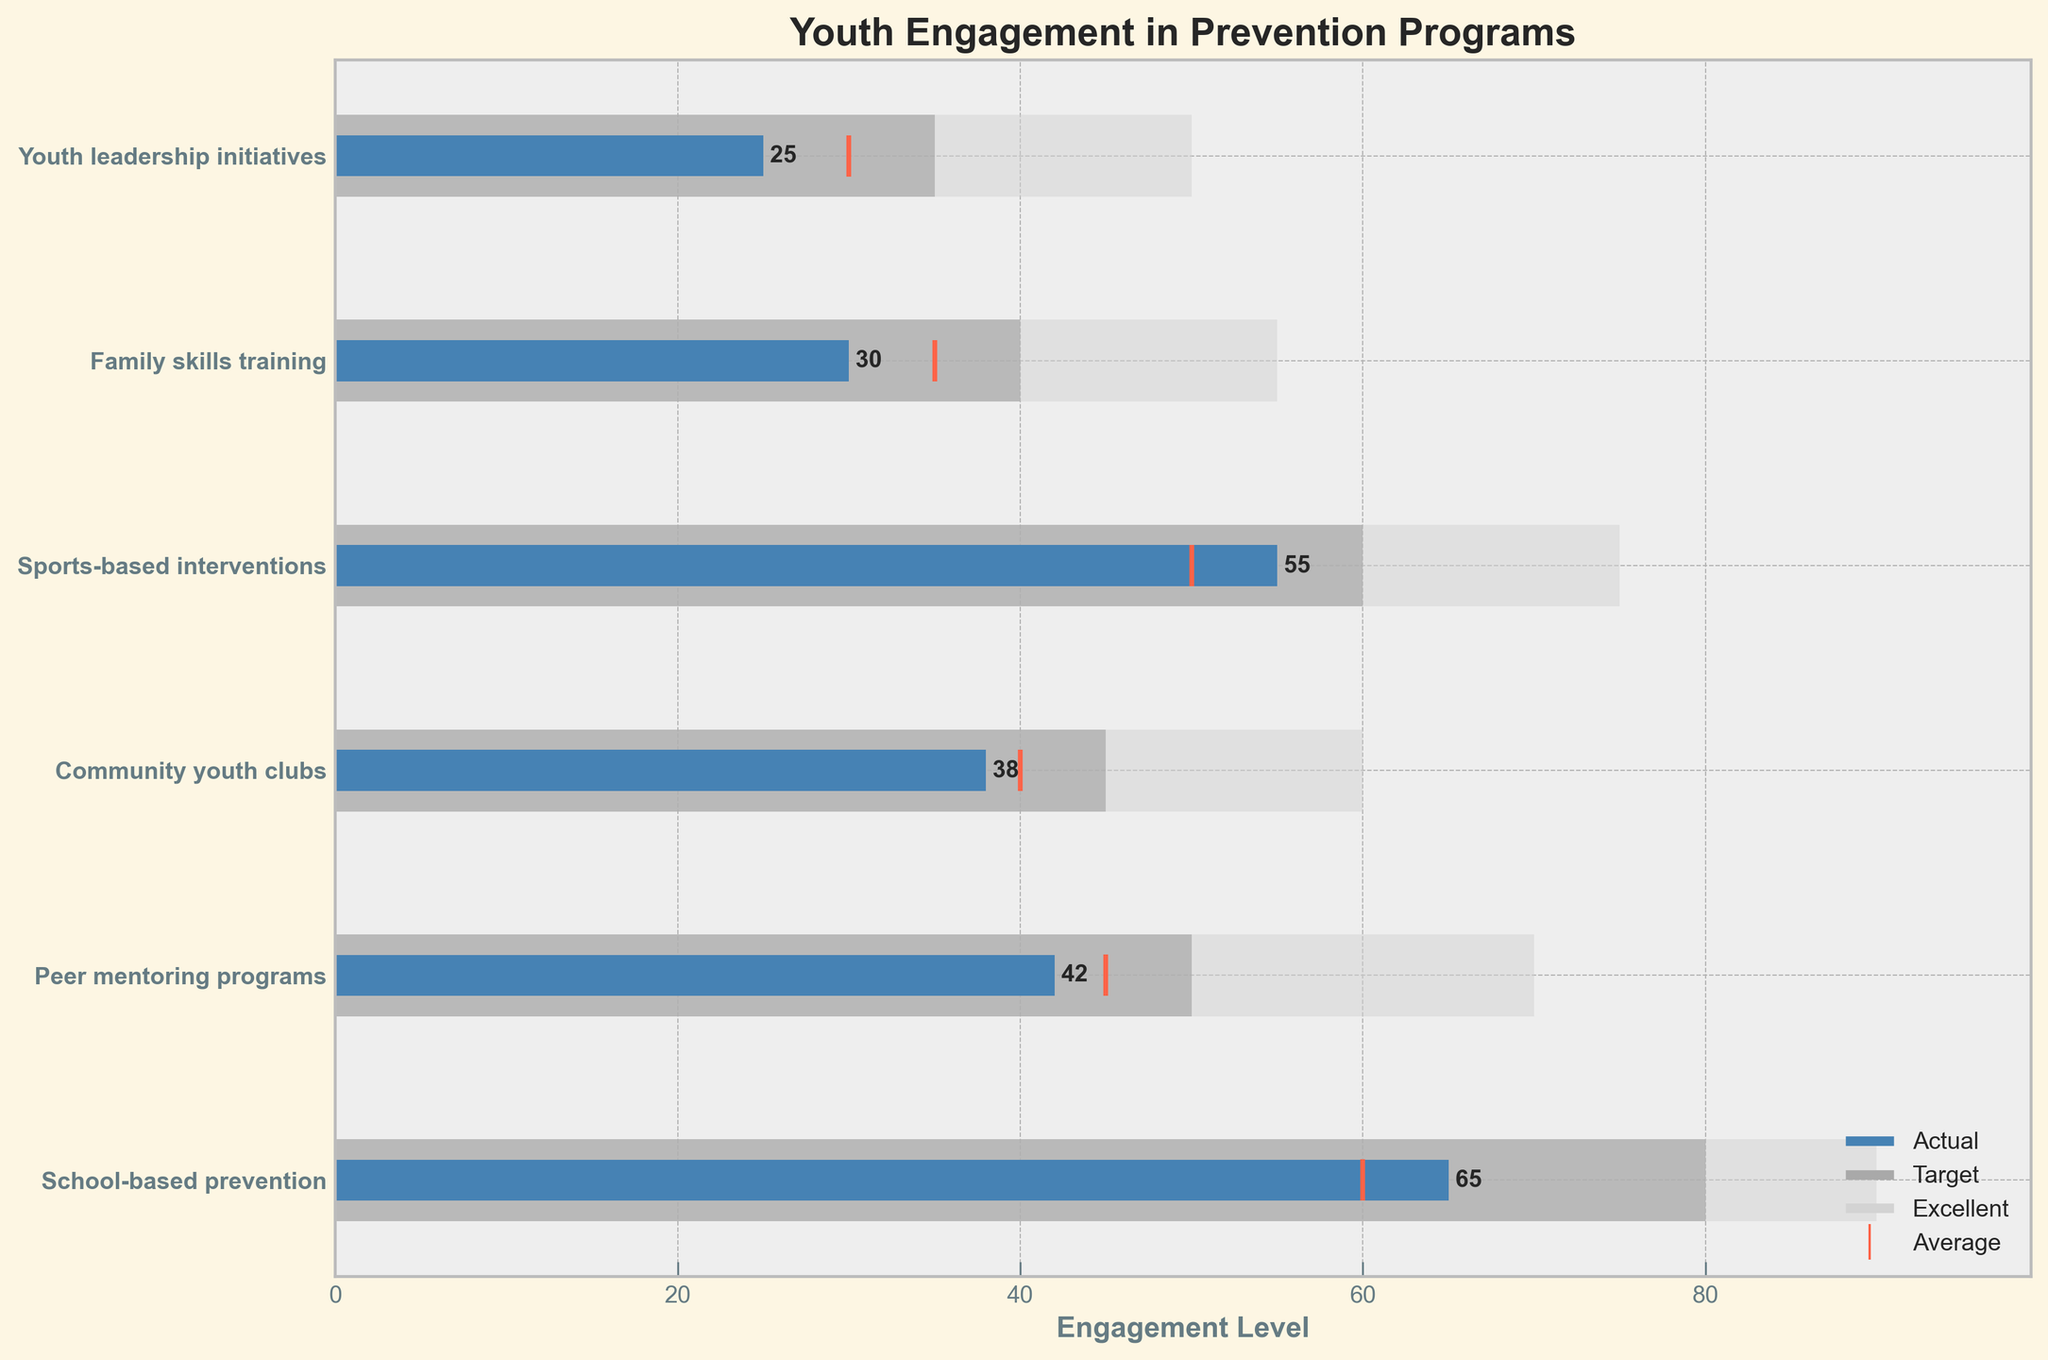what is the title of the figure? The title is usually located at the top of the figure. Here, it reads "Youth Engagement in Prevention Programs."
Answer: Youth Engagement in Prevention Programs how many programs are listed in the figure? By counting the number of program names along the y-axis, we can determine that there are six programs.
Answer: six which program has the highest level of actual engagement? Find the tallest blue bar, which represents 'actual' engagement. The tallest blue bar is for "School-based prevention."
Answer: School-based prevention what is the engagement level that corresponds to the average marker for "Peer mentoring programs"? Locate the 'Peer mentoring programs' row and identify the orange vertical line (marker) on the x-axis. The engagement level is 45.
Answer: 45 how far is "Family skills training" from reaching its target? The target engagement for "Family skills training" is 40, and the actual engagement level is 30. Subtract the actual from the target: 40 - 30.
Answer: 10 which program is closest to meeting its target? For each program, subtract the actual engagement from the target engagement. The smallest difference indicates the closest to meeting the target. "School-based prevention" has an actual of 65 and a target of 80, a difference of 15, which is the smallest.
Answer: School-based prevention which program has the largest gap between actual and excellent engagement levels? Find the difference between the actual and excellent engagement levels for each program and identify the maximum. "Family skills training": 55 - 30 = 25. Other programs have smaller differences.
Answer: Family skills training what is the average actual engagement level across all programs? Sum the actual engagement values for all programs and divide by the number of programs. (65 + 42 + 38 + 55 + 30 + 25) / 6 = 42.5
Answer: 42.5 which two programs have the same average engagement level? Examine the orange markers corresponding to average engagement and match any two programs with the same level. Both "School-based prevention" and "Community youth clubs" have an average engagement level of 40.
Answer: School-based prevention and Community youth clubs which program has the smallest difference between its average and actual engagement levels? Calculate the difference between the average and actual engagement for each program, finding the smallest. "Peer mentoring programs" shows an average of 45 and an actual of 42, yielding a difference of 3.
Answer: Peer mentoring programs 